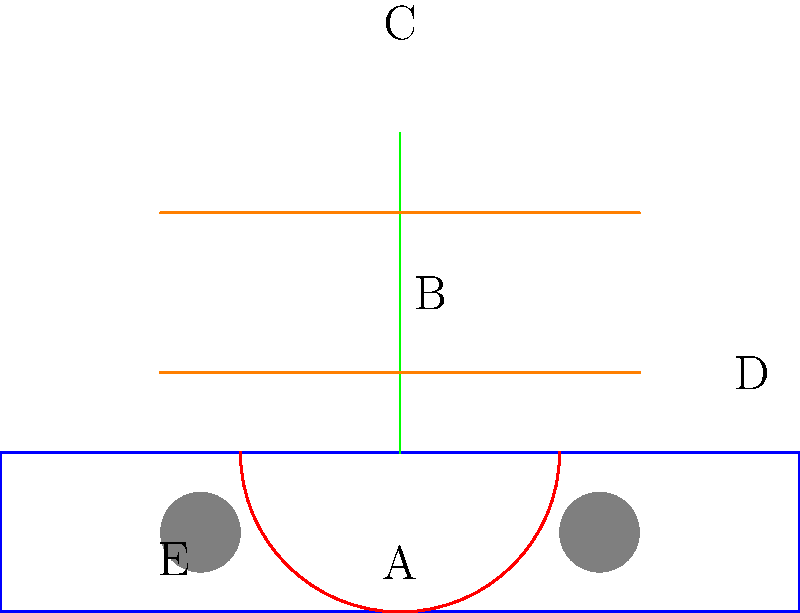In the exploded view diagram of a snowboard binding system, which component is responsible for providing lateral support and allowing the rider to lean back into the binding? To answer this question, let's break down the components of the snowboard binding system shown in the diagram:

1. The base plate (A) is the foundation of the binding, attaching to the snowboard.
2. The heel cup (B) wraps around the back of the boot, securing it in place.
3. The highback (C) is the vertical piece extending upwards from the heel cup.
4. The straps (D) secure the boot to the binding across the top of the foot and ankle.
5. The mounting discs (E) allow for adjustments in the binding's position on the board.

The component responsible for providing lateral support and allowing the rider to lean back into the binding is the highback (C). It serves several important functions:

1. Lateral support: The highback provides support for side-to-side movements, helping the rider maintain control during turns and carves.
2. Lean back support: It allows the rider to lean back into the binding, which is crucial for maintaining balance and control, especially during heel-side turns.
3. Response: The highback transfers energy from the rider's legs to the board, improving overall responsiveness.
4. Customization: Many highbacks can be adjusted for forward lean, allowing riders to fine-tune their stance and riding style.

The highback is typically made of a sturdy, yet flexible material like reinforced plastic or carbon fiber to provide the necessary support while still allowing for some give during impacts and landings.
Answer: Highback 